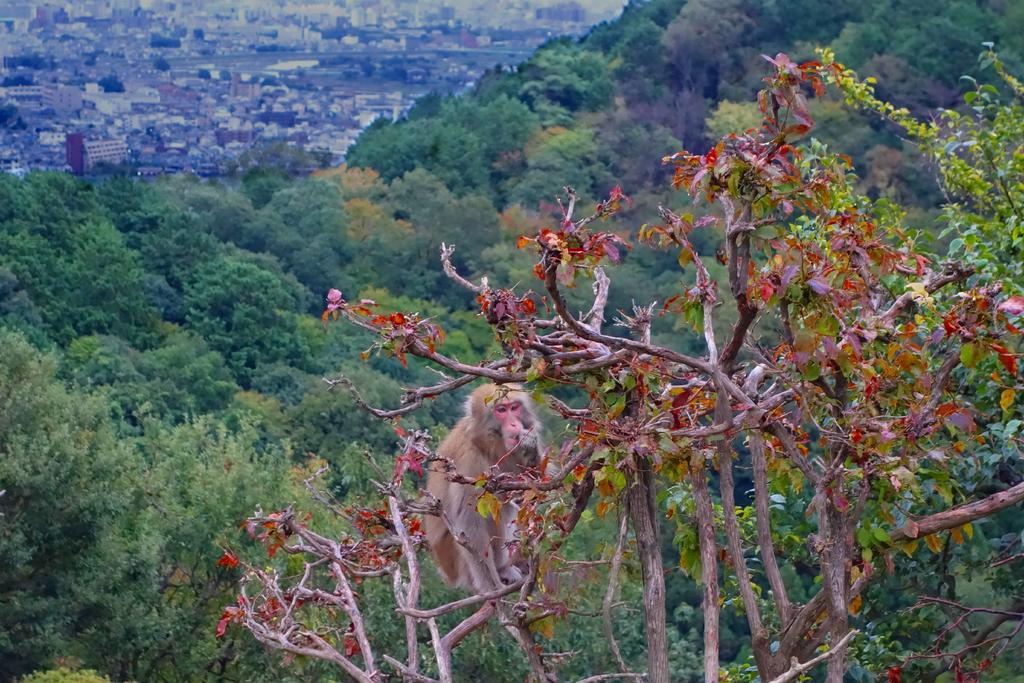What animal is present in the image? There is a monkey in the image. Where is the monkey located? The monkey is on a tree. What is the color of the monkey? The monkey is brown in color. What can be seen in the background of the image? There are trees and buildings in the background of the image. What time does the monkey's mind suggest it is in the image? The image does not provide any information about the time or the monkey's mind, so this question cannot be answered definitively. How many dogs are present in the image? There are no dogs present in the image; it features a monkey on a tree. 